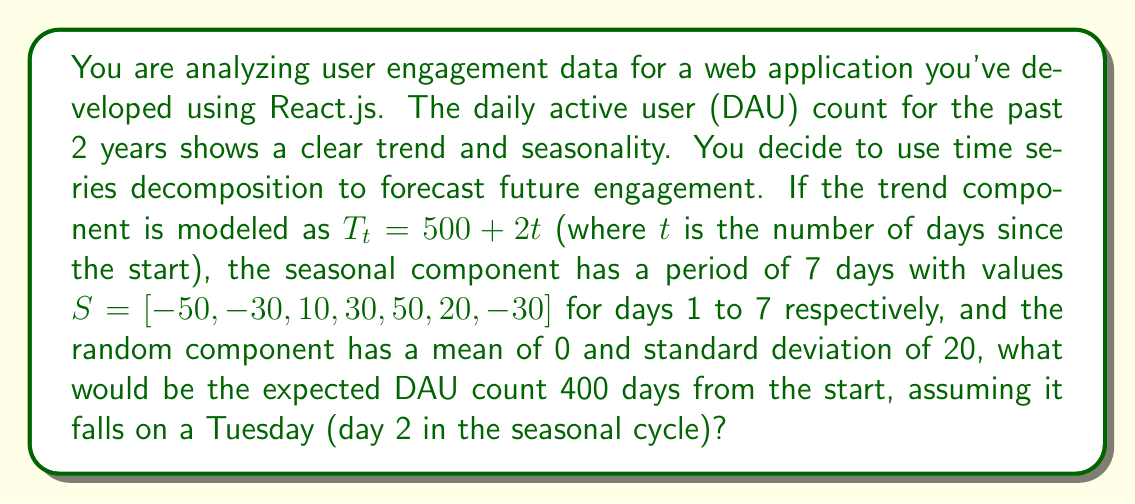Provide a solution to this math problem. To solve this problem, we need to use the additive time series decomposition model:

$$Y_t = T_t + S_t + R_t$$

Where:
$Y_t$ is the observed value at time $t$
$T_t$ is the trend component
$S_t$ is the seasonal component
$R_t$ is the random component

Let's break it down step by step:

1) Trend component ($T_t$):
   Given $T_t = 500 + 2t$ and $t = 400$
   $$T_{400} = 500 + 2(400) = 1300$$

2) Seasonal component ($S_t$):
   Day 400 falls on a Tuesday, which is day 2 in the seasonal cycle.
   $$S_{400} = -30$$

3) Random component ($R_t$):
   The random component has a mean of 0, so for forecasting purposes, we use its expected value:
   $$E[R_t] = 0$$

4) Combining all components:
   $$Y_{400} = T_{400} + S_{400} + E[R_{400}]$$
   $$Y_{400} = 1300 + (-30) + 0 = 1270$$

Therefore, the expected DAU count 400 days from the start would be 1270.
Answer: 1270 daily active users 